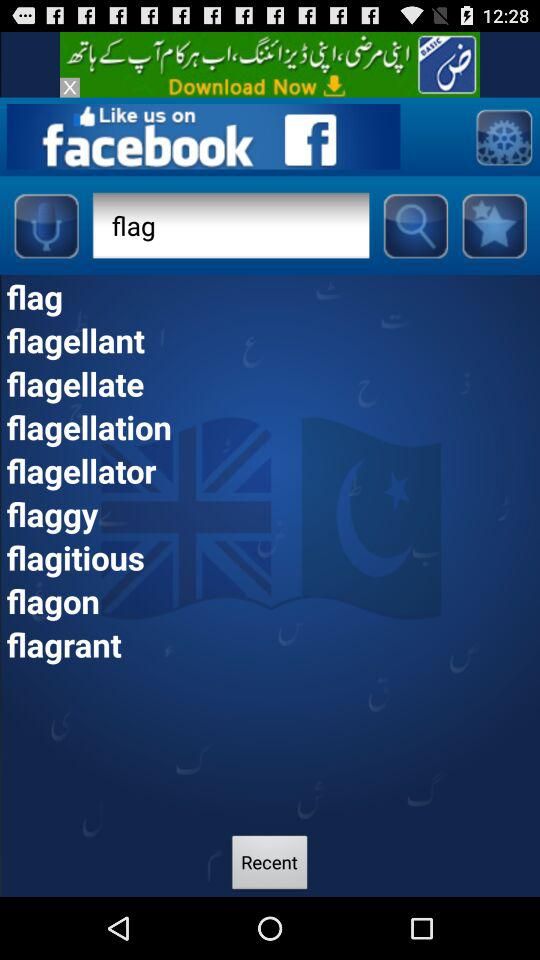How many text input fields are there on the screen?
Answer the question using a single word or phrase. 1 